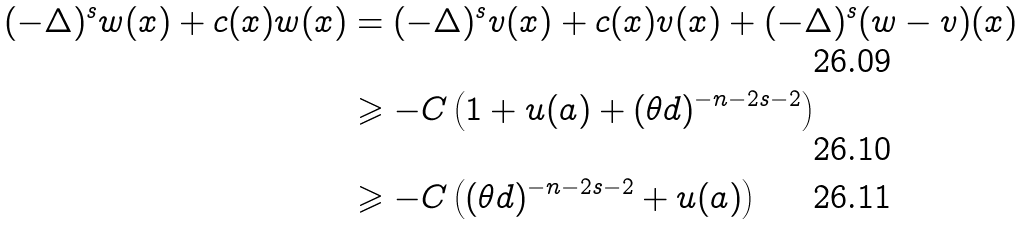<formula> <loc_0><loc_0><loc_500><loc_500>( - \Delta ) ^ { s } w ( x ) + c ( x ) w ( x ) & = ( - \Delta ) ^ { s } v ( x ) + c ( x ) v ( x ) + ( - \Delta ) ^ { s } ( w - v ) ( x ) \\ & \geqslant - C \left ( 1 + u ( a ) + ( \theta d ) ^ { - n - 2 s - 2 } \right ) \\ & \geqslant - C \left ( ( \theta d ) ^ { - n - 2 s - 2 } + u ( a ) \right )</formula> 